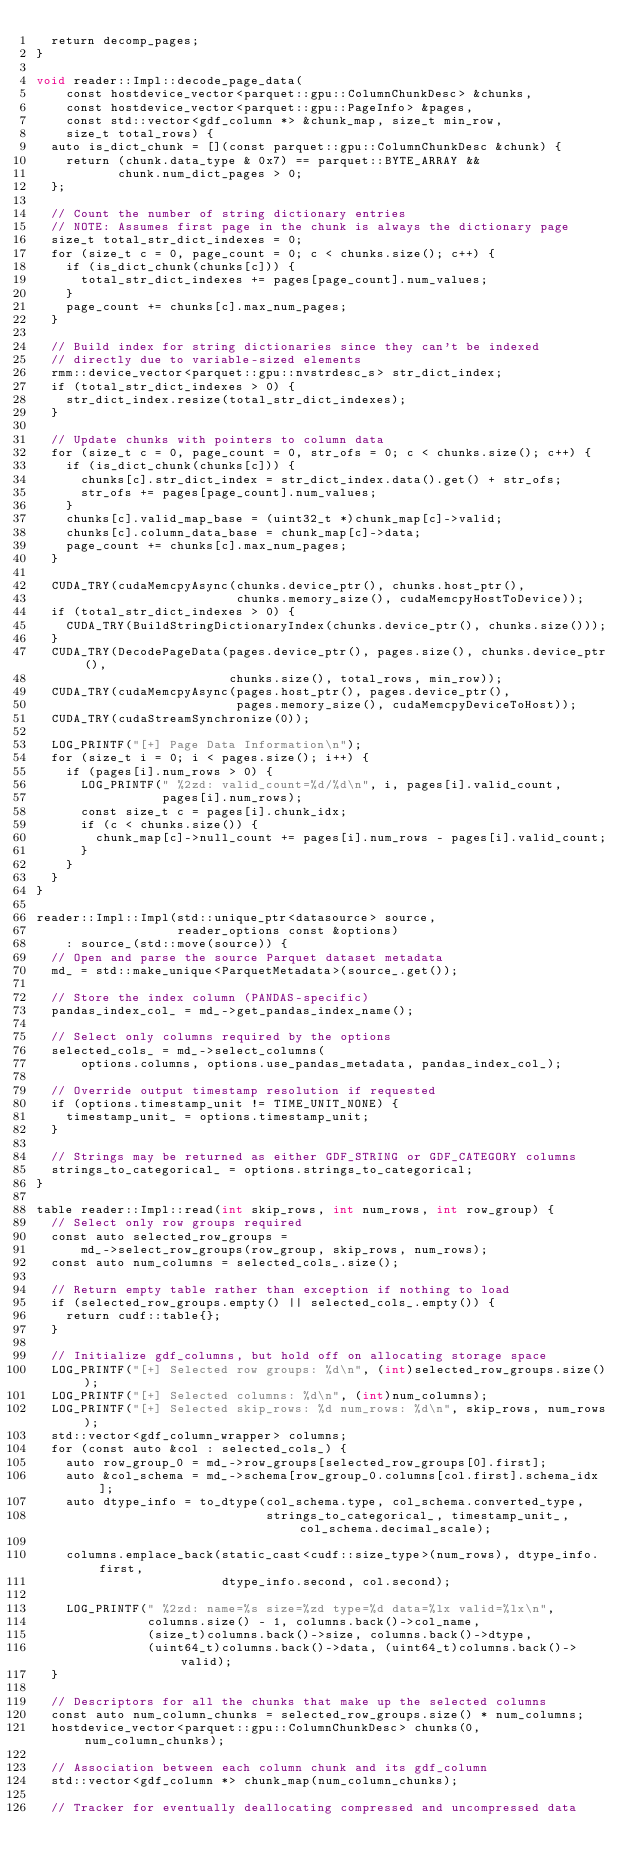<code> <loc_0><loc_0><loc_500><loc_500><_Cuda_>  return decomp_pages;
}

void reader::Impl::decode_page_data(
    const hostdevice_vector<parquet::gpu::ColumnChunkDesc> &chunks,
    const hostdevice_vector<parquet::gpu::PageInfo> &pages,
    const std::vector<gdf_column *> &chunk_map, size_t min_row,
    size_t total_rows) {
  auto is_dict_chunk = [](const parquet::gpu::ColumnChunkDesc &chunk) {
    return (chunk.data_type & 0x7) == parquet::BYTE_ARRAY &&
           chunk.num_dict_pages > 0;
  };

  // Count the number of string dictionary entries
  // NOTE: Assumes first page in the chunk is always the dictionary page
  size_t total_str_dict_indexes = 0;
  for (size_t c = 0, page_count = 0; c < chunks.size(); c++) {
    if (is_dict_chunk(chunks[c])) {
      total_str_dict_indexes += pages[page_count].num_values;
    }
    page_count += chunks[c].max_num_pages;
  }

  // Build index for string dictionaries since they can't be indexed
  // directly due to variable-sized elements
  rmm::device_vector<parquet::gpu::nvstrdesc_s> str_dict_index;
  if (total_str_dict_indexes > 0) {
    str_dict_index.resize(total_str_dict_indexes);
  }

  // Update chunks with pointers to column data
  for (size_t c = 0, page_count = 0, str_ofs = 0; c < chunks.size(); c++) {
    if (is_dict_chunk(chunks[c])) {
      chunks[c].str_dict_index = str_dict_index.data().get() + str_ofs;
      str_ofs += pages[page_count].num_values;
    }
    chunks[c].valid_map_base = (uint32_t *)chunk_map[c]->valid;
    chunks[c].column_data_base = chunk_map[c]->data;
    page_count += chunks[c].max_num_pages;
  }

  CUDA_TRY(cudaMemcpyAsync(chunks.device_ptr(), chunks.host_ptr(),
                           chunks.memory_size(), cudaMemcpyHostToDevice));
  if (total_str_dict_indexes > 0) {
    CUDA_TRY(BuildStringDictionaryIndex(chunks.device_ptr(), chunks.size()));
  }
  CUDA_TRY(DecodePageData(pages.device_ptr(), pages.size(), chunks.device_ptr(),
                          chunks.size(), total_rows, min_row));
  CUDA_TRY(cudaMemcpyAsync(pages.host_ptr(), pages.device_ptr(),
                           pages.memory_size(), cudaMemcpyDeviceToHost));
  CUDA_TRY(cudaStreamSynchronize(0));

  LOG_PRINTF("[+] Page Data Information\n");
  for (size_t i = 0; i < pages.size(); i++) {
    if (pages[i].num_rows > 0) {
      LOG_PRINTF(" %2zd: valid_count=%d/%d\n", i, pages[i].valid_count,
                 pages[i].num_rows);
      const size_t c = pages[i].chunk_idx;
      if (c < chunks.size()) {
        chunk_map[c]->null_count += pages[i].num_rows - pages[i].valid_count;
      }
    }
  }
}

reader::Impl::Impl(std::unique_ptr<datasource> source,
                   reader_options const &options)
    : source_(std::move(source)) {
  // Open and parse the source Parquet dataset metadata
  md_ = std::make_unique<ParquetMetadata>(source_.get());

  // Store the index column (PANDAS-specific)
  pandas_index_col_ = md_->get_pandas_index_name();

  // Select only columns required by the options
  selected_cols_ = md_->select_columns(
      options.columns, options.use_pandas_metadata, pandas_index_col_);

  // Override output timestamp resolution if requested
  if (options.timestamp_unit != TIME_UNIT_NONE) {
    timestamp_unit_ = options.timestamp_unit;
  }

  // Strings may be returned as either GDF_STRING or GDF_CATEGORY columns
  strings_to_categorical_ = options.strings_to_categorical;
}

table reader::Impl::read(int skip_rows, int num_rows, int row_group) {
  // Select only row groups required
  const auto selected_row_groups =
      md_->select_row_groups(row_group, skip_rows, num_rows);
  const auto num_columns = selected_cols_.size();

  // Return empty table rather than exception if nothing to load
  if (selected_row_groups.empty() || selected_cols_.empty()) {
    return cudf::table{};
  }

  // Initialize gdf_columns, but hold off on allocating storage space
  LOG_PRINTF("[+] Selected row groups: %d\n", (int)selected_row_groups.size());
  LOG_PRINTF("[+] Selected columns: %d\n", (int)num_columns);
  LOG_PRINTF("[+] Selected skip_rows: %d num_rows: %d\n", skip_rows, num_rows);
  std::vector<gdf_column_wrapper> columns;
  for (const auto &col : selected_cols_) {
    auto row_group_0 = md_->row_groups[selected_row_groups[0].first];
    auto &col_schema = md_->schema[row_group_0.columns[col.first].schema_idx];
    auto dtype_info = to_dtype(col_schema.type, col_schema.converted_type,
                               strings_to_categorical_, timestamp_unit_, col_schema.decimal_scale);

    columns.emplace_back(static_cast<cudf::size_type>(num_rows), dtype_info.first,
                         dtype_info.second, col.second);

    LOG_PRINTF(" %2zd: name=%s size=%zd type=%d data=%lx valid=%lx\n",
               columns.size() - 1, columns.back()->col_name,
               (size_t)columns.back()->size, columns.back()->dtype,
               (uint64_t)columns.back()->data, (uint64_t)columns.back()->valid);
  }

  // Descriptors for all the chunks that make up the selected columns
  const auto num_column_chunks = selected_row_groups.size() * num_columns;
  hostdevice_vector<parquet::gpu::ColumnChunkDesc> chunks(0, num_column_chunks);

  // Association between each column chunk and its gdf_column
  std::vector<gdf_column *> chunk_map(num_column_chunks);

  // Tracker for eventually deallocating compressed and uncompressed data</code> 